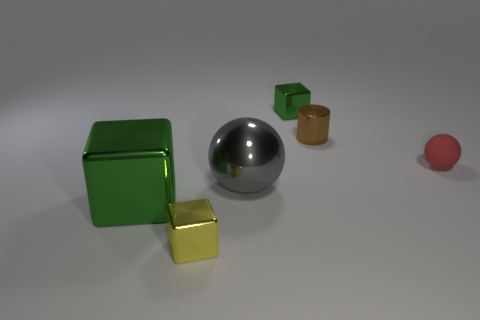Add 1 small green shiny objects. How many objects exist? 7 Subtract all cylinders. How many objects are left? 5 Add 6 shiny cubes. How many shiny cubes are left? 9 Add 5 big green blocks. How many big green blocks exist? 6 Subtract 1 red balls. How many objects are left? 5 Subtract all tiny yellow metallic blocks. Subtract all small cyan things. How many objects are left? 5 